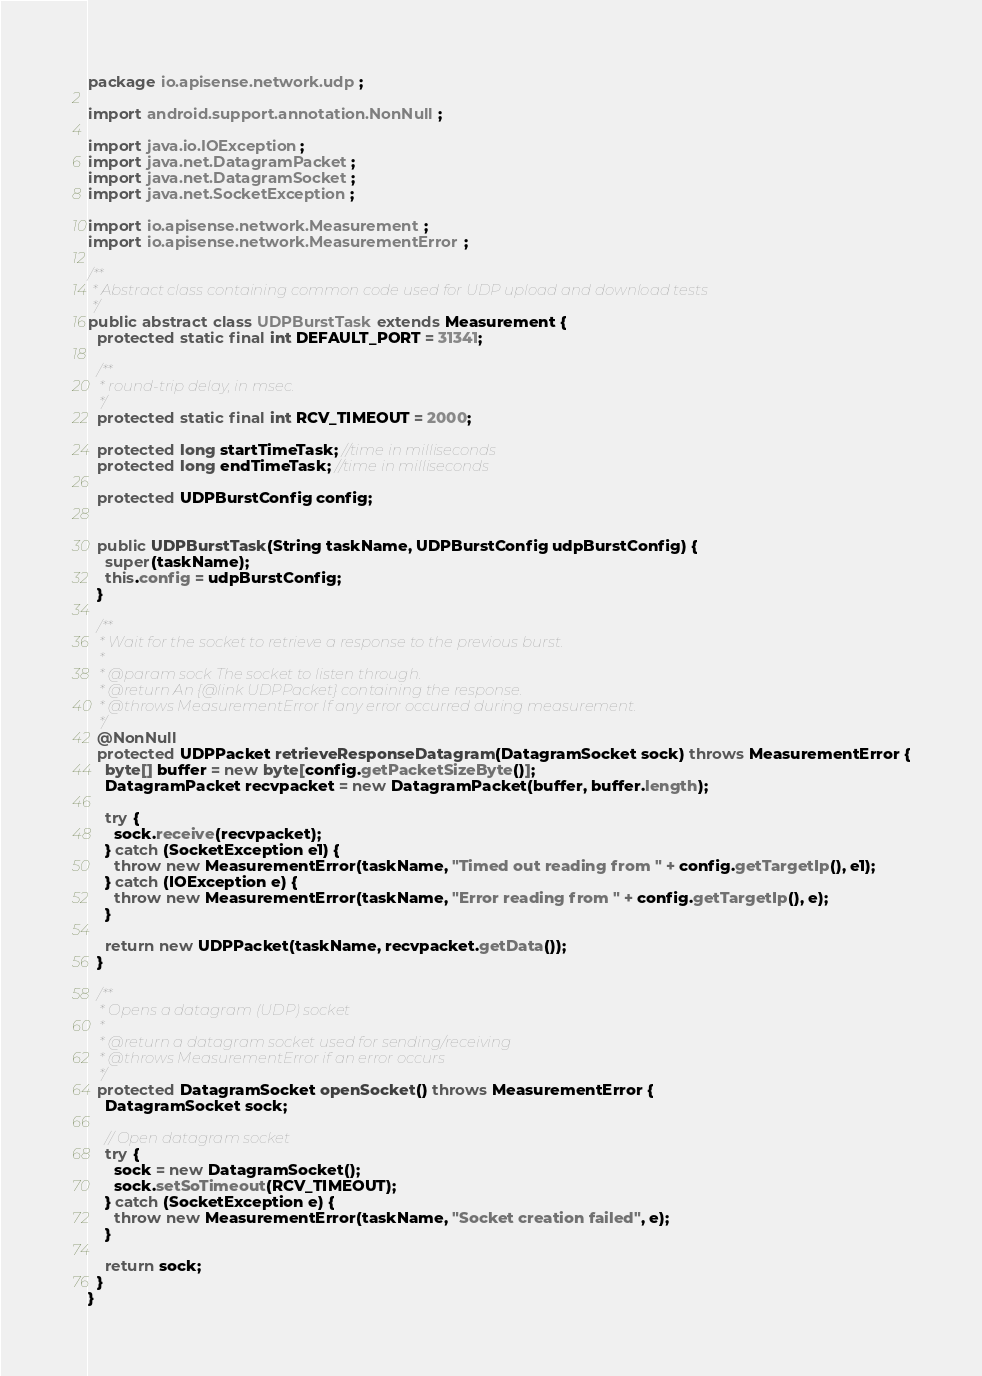Convert code to text. <code><loc_0><loc_0><loc_500><loc_500><_Java_>package io.apisense.network.udp;

import android.support.annotation.NonNull;

import java.io.IOException;
import java.net.DatagramPacket;
import java.net.DatagramSocket;
import java.net.SocketException;

import io.apisense.network.Measurement;
import io.apisense.network.MeasurementError;

/**
 * Abstract class containing common code used for UDP upload and download tests
 */
public abstract class UDPBurstTask extends Measurement {
  protected static final int DEFAULT_PORT = 31341;

  /**
   * round-trip delay, in msec.
   */
  protected static final int RCV_TIMEOUT = 2000;

  protected long startTimeTask; //time in milliseconds
  protected long endTimeTask; //time in milliseconds

  protected UDPBurstConfig config;


  public UDPBurstTask(String taskName, UDPBurstConfig udpBurstConfig) {
    super(taskName);
    this.config = udpBurstConfig;
  }

  /**
   * Wait for the socket to retrieve a response to the previous burst.
   *
   * @param sock The socket to listen through.
   * @return An {@link UDPPacket} containing the response.
   * @throws MeasurementError If any error occurred during measurement.
   */
  @NonNull
  protected UDPPacket retrieveResponseDatagram(DatagramSocket sock) throws MeasurementError {
    byte[] buffer = new byte[config.getPacketSizeByte()];
    DatagramPacket recvpacket = new DatagramPacket(buffer, buffer.length);

    try {
      sock.receive(recvpacket);
    } catch (SocketException e1) {
      throw new MeasurementError(taskName, "Timed out reading from " + config.getTargetIp(), e1);
    } catch (IOException e) {
      throw new MeasurementError(taskName, "Error reading from " + config.getTargetIp(), e);
    }

    return new UDPPacket(taskName, recvpacket.getData());
  }

  /**
   * Opens a datagram (UDP) socket
   *
   * @return a datagram socket used for sending/receiving
   * @throws MeasurementError if an error occurs
   */
  protected DatagramSocket openSocket() throws MeasurementError {
    DatagramSocket sock;

    // Open datagram socket
    try {
      sock = new DatagramSocket();
      sock.setSoTimeout(RCV_TIMEOUT);
    } catch (SocketException e) {
      throw new MeasurementError(taskName, "Socket creation failed", e);
    }

    return sock;
  }
}
</code> 